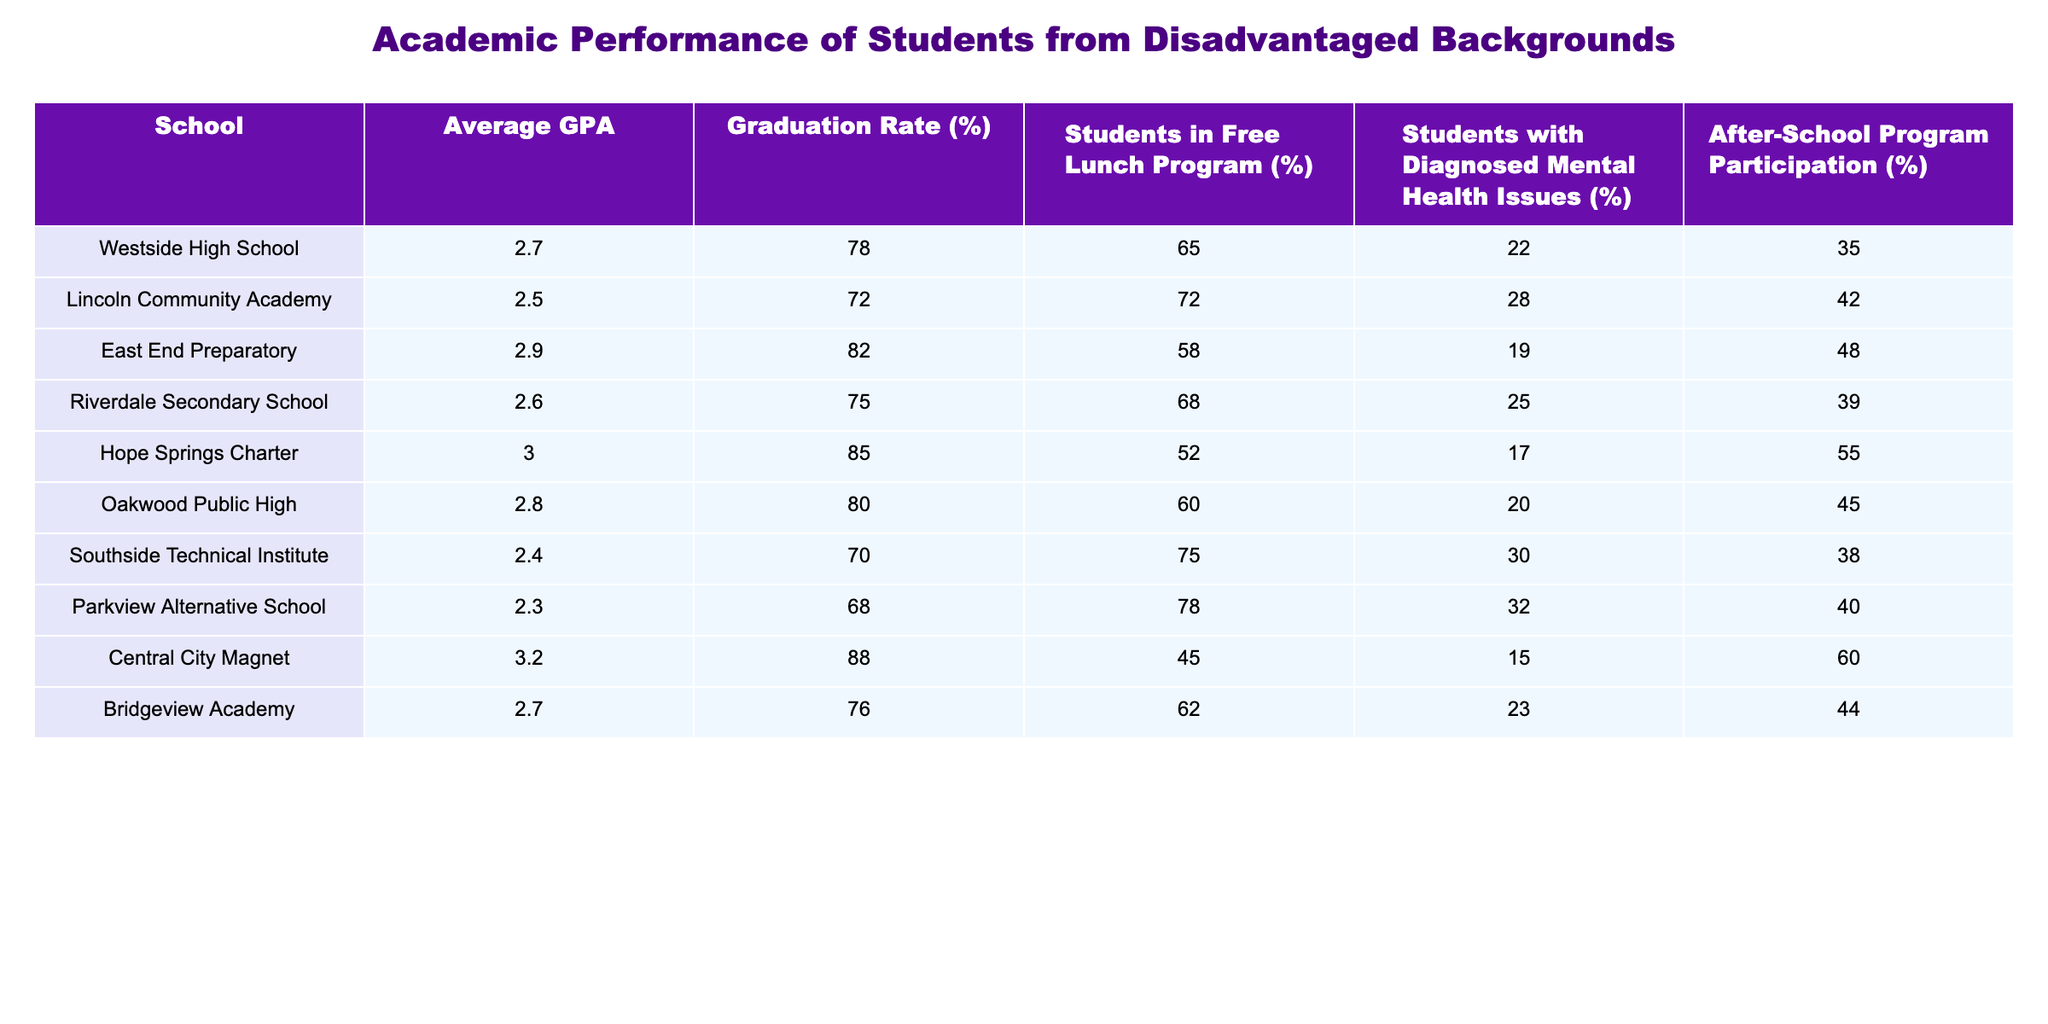What school has the highest average GPA? By inspecting the "Average GPA" column, Central City Magnet has the highest value of 3.2.
Answer: Central City Magnet What is the graduation rate of Hope Springs Charter? Looking at the "Graduation Rate (%)" column, Hope Springs Charter shows a rate of 85%.
Answer: 85% Which school has the highest percentage of students in the free lunch program? The "Students in Free Lunch Program (%)" column indicates that Southside Technical Institute has the highest percentage at 75%.
Answer: 75% Is the average GPA of Parkview Alternative School below 3.0? Checking the "Average GPA" for Parkview Alternative, it is 2.3, which is below 3.0.
Answer: Yes What is the difference in graduation rates between Central City Magnet and Lincoln Community Academy? Central City Magnet has a graduation rate of 88% and Lincoln Community Academy has 72%. The difference is 88 - 72 = 16%.
Answer: 16% What percentage of students at Lincoln Community Academy have diagnosed mental health issues? Referring to the "Students with Diagnosed Mental Health Issues (%)" column, Lincoln Community Academy has 28%.
Answer: 28% What is the average GPA of schools that have a graduation rate above 80%? The schools with graduation rates above 80% are East End Preparatory (2.9), Hope Springs Charter (3.0), and Central City Magnet (3.2). The average GPA is (2.9 + 3.0 + 3.2) / 3 = 3.033.
Answer: 3.033 Is there a school with both a low average GPA and low graduation rate? Yes, Parkview Alternative School has a low average GPA of 2.3 and a low graduation rate of 68%.
Answer: Yes What is the percentage of students with diagnosed mental health issues in schools where less than 60% of students participate in after-school programs? The schools with less than 60% participation in after-school programs are Hope Springs Charter (55%) and Central City Magnet (60%). The percentages of students with diagnosed mental health issues are 17% and 15%, respectively.
Answer: 17% and 15% What school shows the least participation in after-school programs? By examining the "After-School Program Participation (%)" column, Southside Technical Institute has the least participation at 38%.
Answer: 38% 